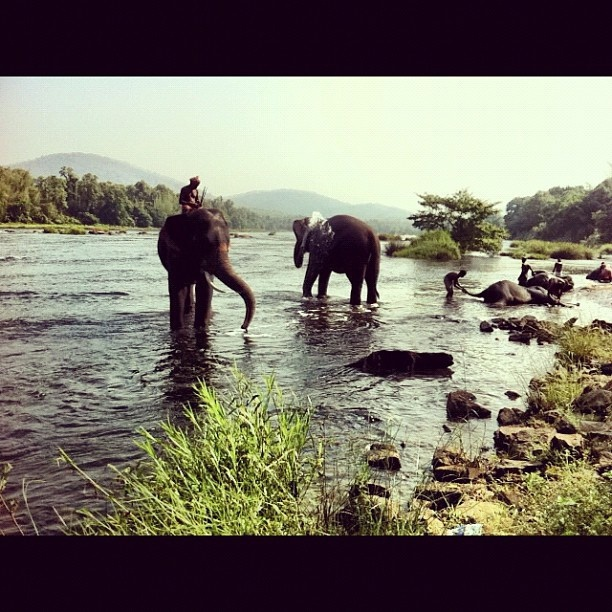Describe the objects in this image and their specific colors. I can see elephant in black and gray tones, elephant in black, gray, and darkgray tones, elephant in black, gray, and darkgray tones, people in black, maroon, brown, and gray tones, and elephant in black, gray, and darkgray tones in this image. 